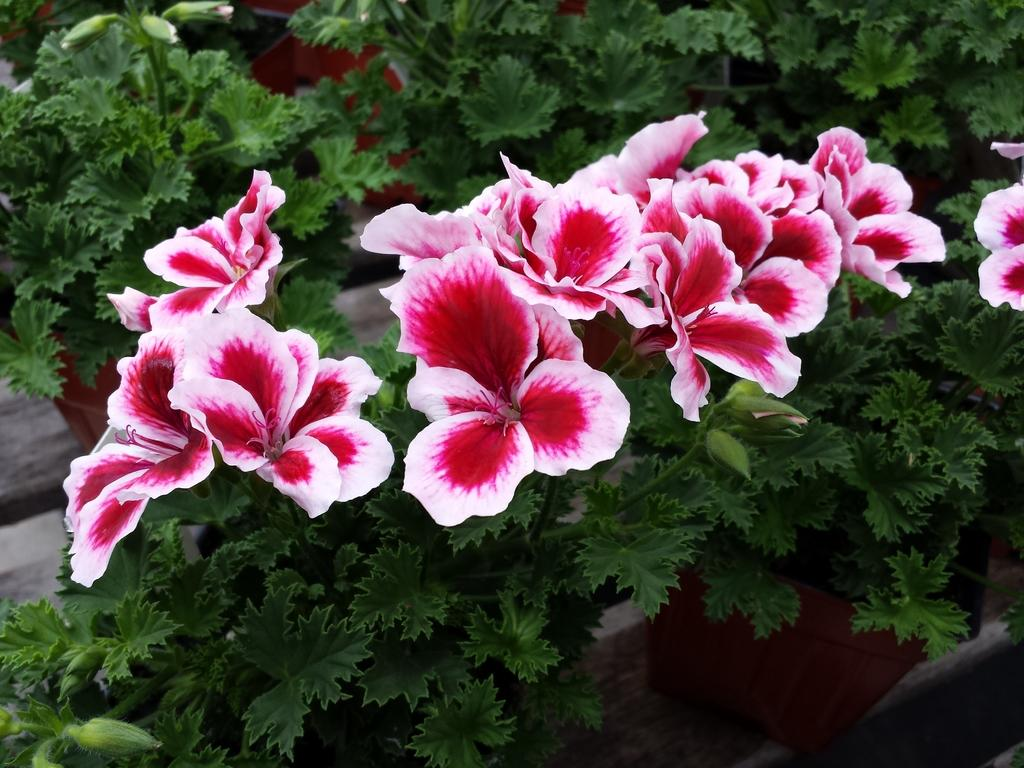What type of plants are in the image? There are house plants in the image. What feature do the house plants have? The house plants have flowers. How are the house plants positioned in the image? The house plants are on platforms. What type of oatmeal is being served to the goldfish in the image? There is no oatmeal or goldfish present in the image; it features house plants on platforms. Is the queen present in the image? There is no queen present in the image; it features house plants on platforms. 